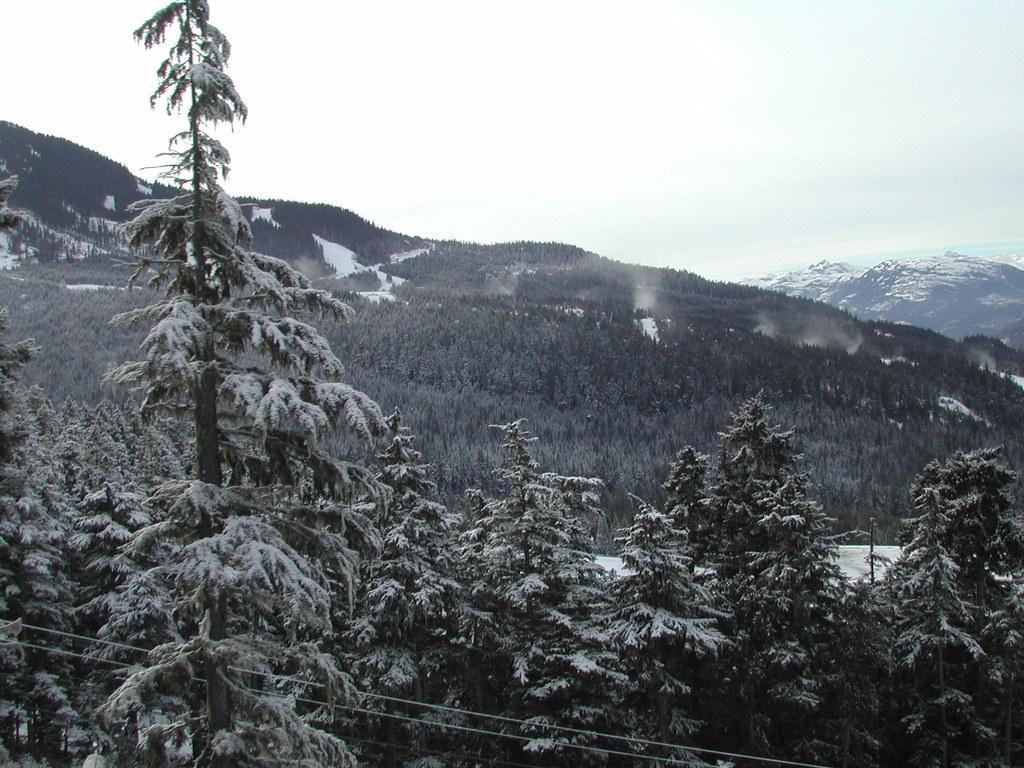How would you summarize this image in a sentence or two? In this picture there are few trees and mountains covered with snow. 